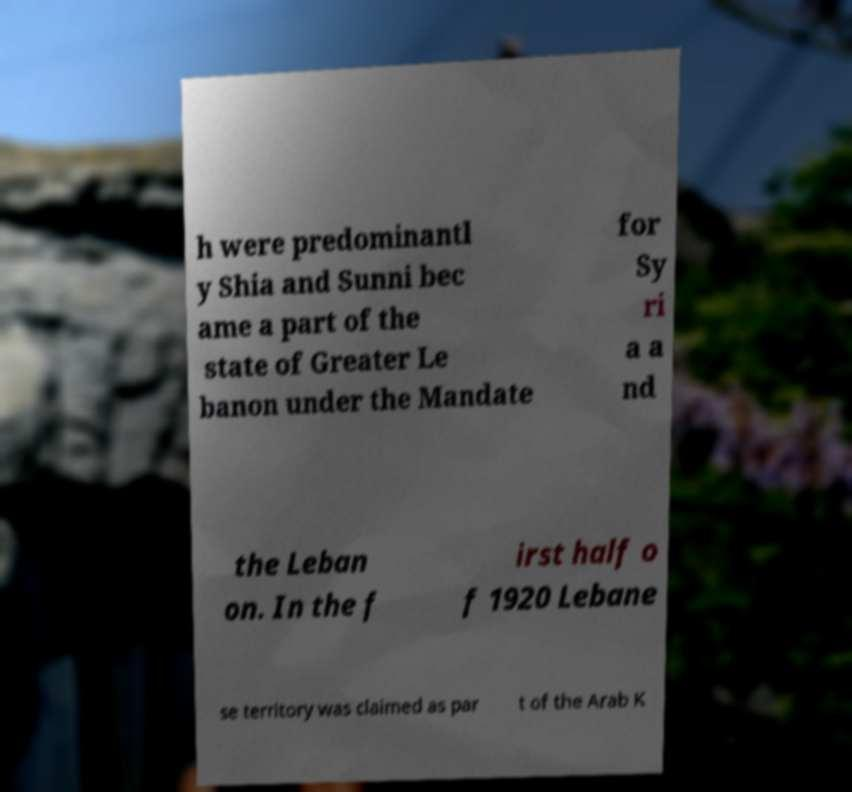There's text embedded in this image that I need extracted. Can you transcribe it verbatim? h were predominantl y Shia and Sunni bec ame a part of the state of Greater Le banon under the Mandate for Sy ri a a nd the Leban on. In the f irst half o f 1920 Lebane se territory was claimed as par t of the Arab K 